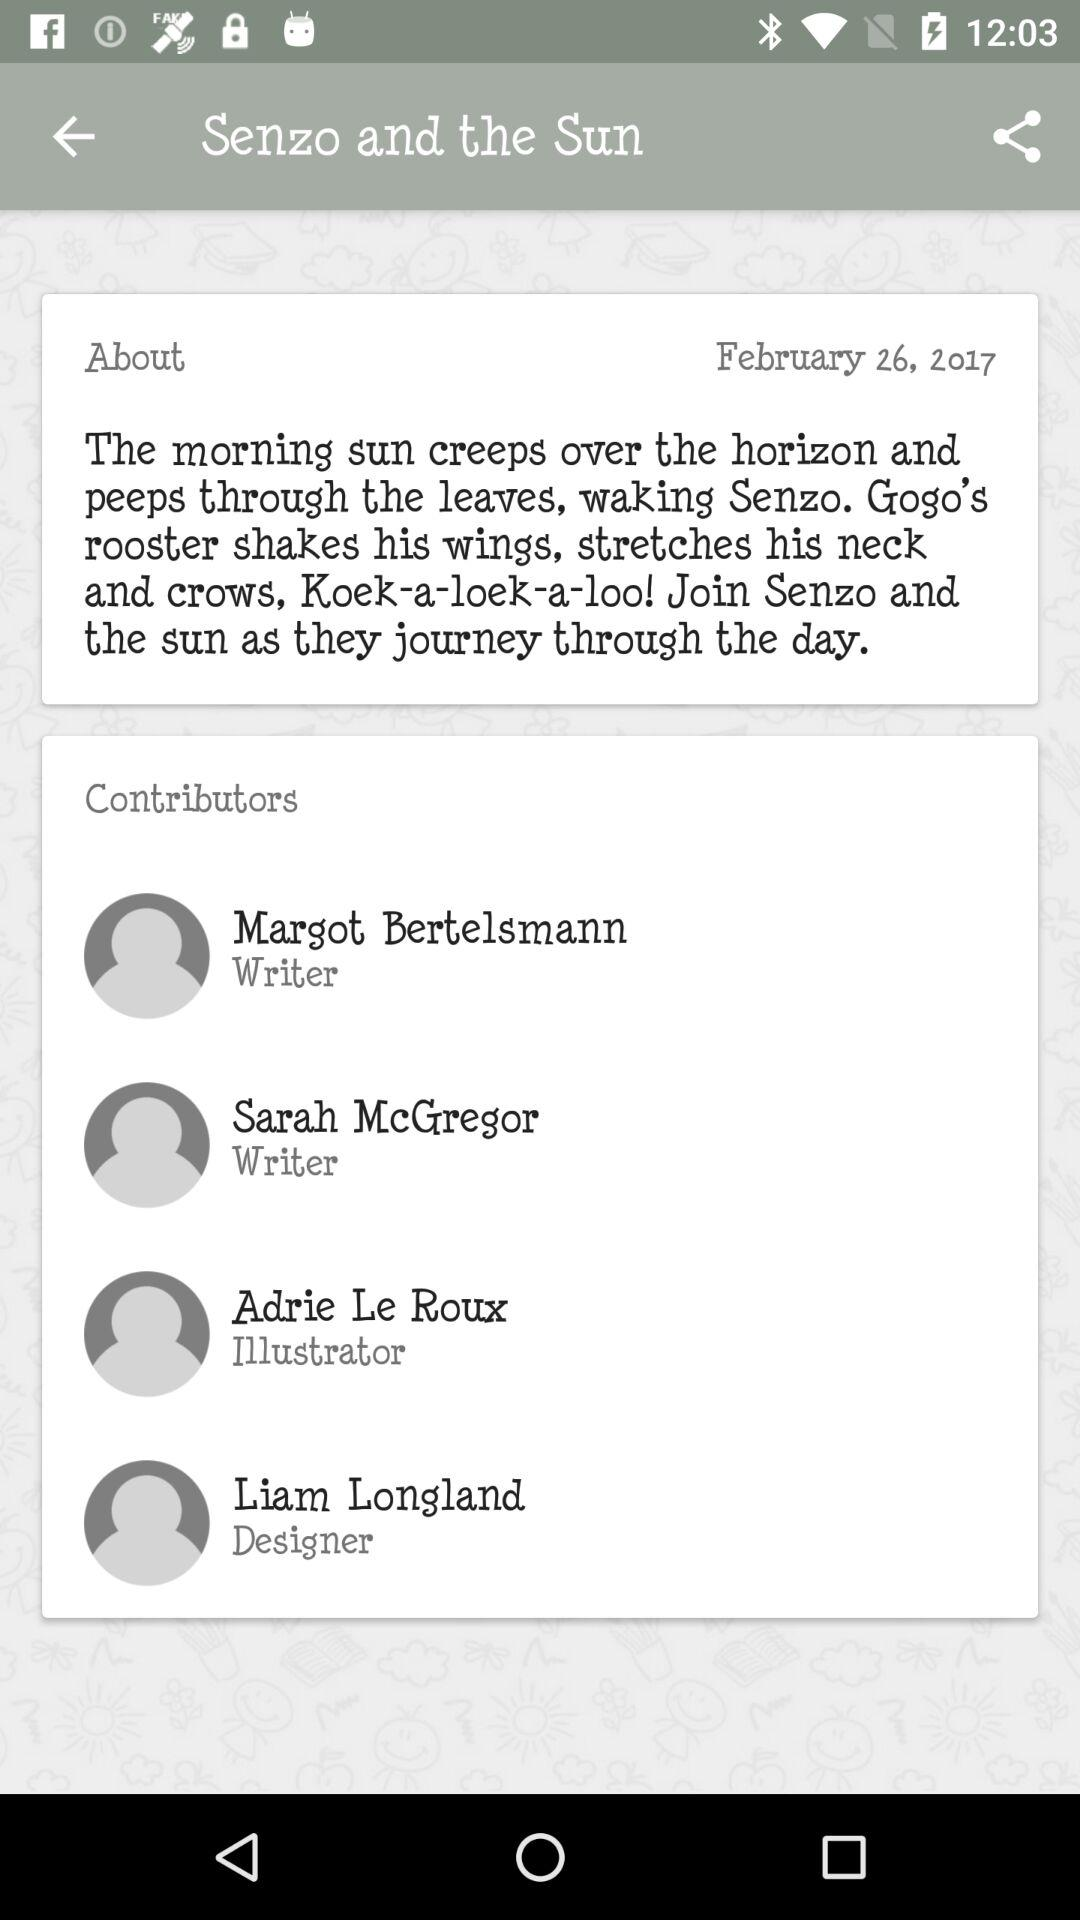What is the book name? The book name is "Senzo and the Sun". 